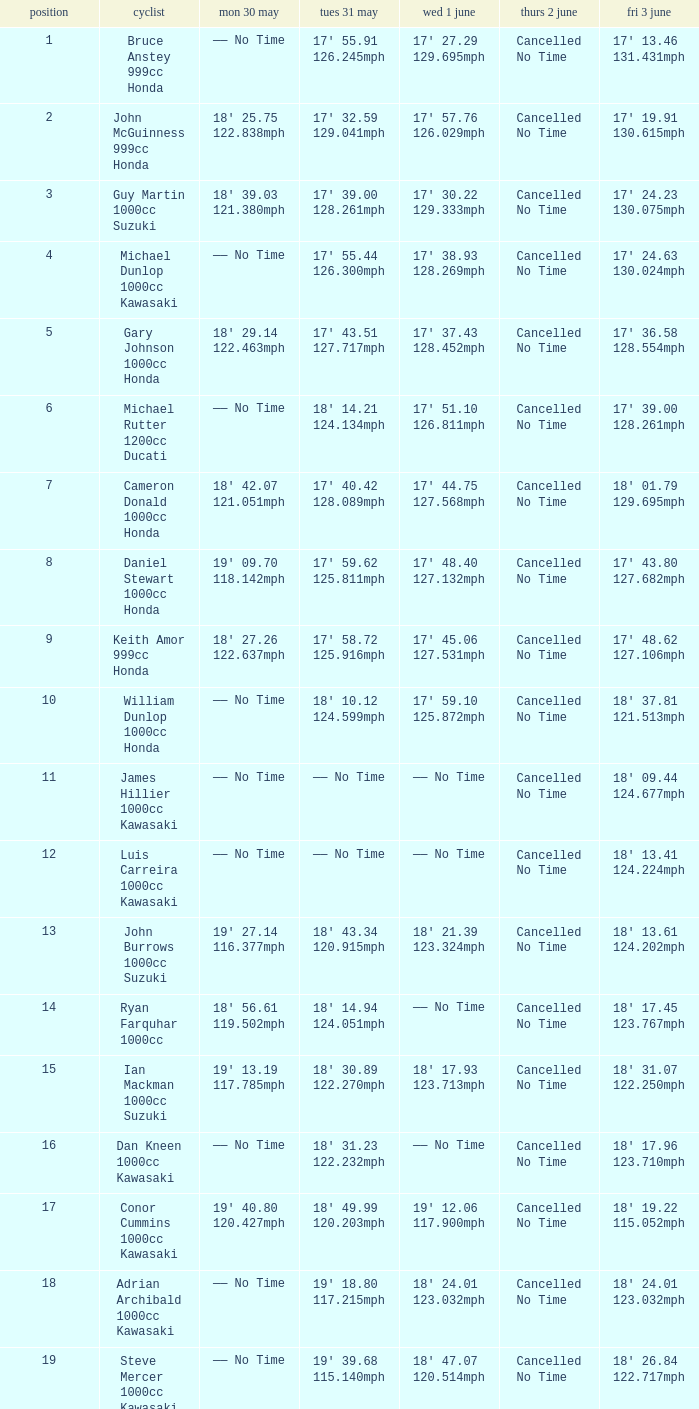What is the Mon 30 May time for the rider whose Fri 3 June time was 17' 13.46 131.431mph? —— No Time. Could you parse the entire table as a dict? {'header': ['position', 'cyclist', 'mon 30 may', 'tues 31 may', 'wed 1 june', 'thurs 2 june', 'fri 3 june'], 'rows': [['1', 'Bruce Anstey 999cc Honda', '—— No Time', "17' 55.91 126.245mph", "17' 27.29 129.695mph", 'Cancelled No Time', "17' 13.46 131.431mph"], ['2', 'John McGuinness 999cc Honda', "18' 25.75 122.838mph", "17' 32.59 129.041mph", "17' 57.76 126.029mph", 'Cancelled No Time', "17' 19.91 130.615mph"], ['3', 'Guy Martin 1000cc Suzuki', "18' 39.03 121.380mph", "17' 39.00 128.261mph", "17' 30.22 129.333mph", 'Cancelled No Time', "17' 24.23 130.075mph"], ['4', 'Michael Dunlop 1000cc Kawasaki', '—— No Time', "17' 55.44 126.300mph", "17' 38.93 128.269mph", 'Cancelled No Time', "17' 24.63 130.024mph"], ['5', 'Gary Johnson 1000cc Honda', "18' 29.14 122.463mph", "17' 43.51 127.717mph", "17' 37.43 128.452mph", 'Cancelled No Time', "17' 36.58 128.554mph"], ['6', 'Michael Rutter 1200cc Ducati', '—— No Time', "18' 14.21 124.134mph", "17' 51.10 126.811mph", 'Cancelled No Time', "17' 39.00 128.261mph"], ['7', 'Cameron Donald 1000cc Honda', "18' 42.07 121.051mph", "17' 40.42 128.089mph", "17' 44.75 127.568mph", 'Cancelled No Time', "18' 01.79 129.695mph"], ['8', 'Daniel Stewart 1000cc Honda', "19' 09.70 118.142mph", "17' 59.62 125.811mph", "17' 48.40 127.132mph", 'Cancelled No Time', "17' 43.80 127.682mph"], ['9', 'Keith Amor 999cc Honda', "18' 27.26 122.637mph", "17' 58.72 125.916mph", "17' 45.06 127.531mph", 'Cancelled No Time', "17' 48.62 127.106mph"], ['10', 'William Dunlop 1000cc Honda', '—— No Time', "18' 10.12 124.599mph", "17' 59.10 125.872mph", 'Cancelled No Time', "18' 37.81 121.513mph"], ['11', 'James Hillier 1000cc Kawasaki', '—— No Time', '—— No Time', '—— No Time', 'Cancelled No Time', "18' 09.44 124.677mph"], ['12', 'Luis Carreira 1000cc Kawasaki', '—— No Time', '—— No Time', '—— No Time', 'Cancelled No Time', "18' 13.41 124.224mph"], ['13', 'John Burrows 1000cc Suzuki', "19' 27.14 116.377mph", "18' 43.34 120.915mph", "18' 21.39 123.324mph", 'Cancelled No Time', "18' 13.61 124.202mph"], ['14', 'Ryan Farquhar 1000cc', "18' 56.61 119.502mph", "18' 14.94 124.051mph", '—— No Time', 'Cancelled No Time', "18' 17.45 123.767mph"], ['15', 'Ian Mackman 1000cc Suzuki', "19' 13.19 117.785mph", "18' 30.89 122.270mph", "18' 17.93 123.713mph", 'Cancelled No Time', "18' 31.07 122.250mph"], ['16', 'Dan Kneen 1000cc Kawasaki', '—— No Time', "18' 31.23 122.232mph", '—— No Time', 'Cancelled No Time', "18' 17.96 123.710mph"], ['17', 'Conor Cummins 1000cc Kawasaki', "19' 40.80 120.427mph", "18' 49.99 120.203mph", "19' 12.06 117.900mph", 'Cancelled No Time', "18' 19.22 115.052mph"], ['18', 'Adrian Archibald 1000cc Kawasaki', '—— No Time', "19' 18.80 117.215mph", "18' 24.01 123.032mph", 'Cancelled No Time', "18' 24.01 123.032mph"], ['19', 'Steve Mercer 1000cc Kawasaki', '—— No Time', "19' 39.68 115.140mph", "18' 47.07 120.514mph", 'Cancelled No Time', "18' 26.84 122.717mph"]]} 